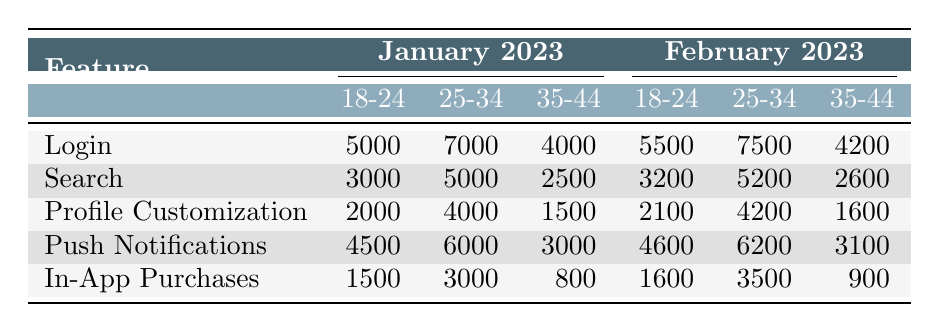What is the total number of Logins in January 2023 for the 25-34 age group? The Logins for the 25-34 age group in January 2023 are listed as 7000. Thus, the total number is 7000.
Answer: 7000 What was the usage of In-App Purchases by the 35-44 age group in February 2023? The In-App Purchases for the 35-44 age group in February 2023 are listed as 900. Therefore, the answer is 900.
Answer: 900 Which feature had the highest usage among the 18-24 age group in January 2023? The usages for the 18-24 age group in January 2023 are: Login (5000), Search (3000), Profile Customization (2000), Push Notifications (4500), and In-App Purchases (1500). The highest value is for Login at 5000.
Answer: Login Is the total number of Push Notifications in February 2023 greater than in January 2023 for the 25-34 age group? For January 2023, Push Notifications for the 25-34 age group are 6000, while in February 2023 it is 6200. Since 6200 is greater than 6000, the answer is yes.
Answer: Yes What is the difference in total Login usage for the 35-44 age group between January and February 2023? In January 2023, the Logins for the 35-44 age group are 4000, while in February 2023 they are 4200. The difference is calculated as 4200 - 4000 = 200.
Answer: 200 What was the average usage of Profile Customization among all age groups in February 2023? The usage in February 2023 for Profile Customization is: 2100 (18-24) + 4200 (25-34) + 1600 (35-44) = 7900. Dividing by the number of age groups, which is 3 gives an average of 7900 / 3 = 2633.33.
Answer: 2633.33 Did the 18-24 age group log more Push Notifications in February 2023 compared to January 2023? In January 2023, Push Notifications for the 18-24 age group are 4500, and in February 2023 it is 4600. Since 4600 is greater than 4500, the answer is yes.
Answer: Yes What was the total usage of In-App Purchases across all age groups in January 2023? The In-App Purchases for January 2023 are: 1500 (18-24) + 3000 (25-34) + 800 (35-44) = 5300. Therefore, the total is 5300.
Answer: 5300 